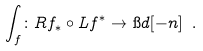<formula> <loc_0><loc_0><loc_500><loc_500>\int _ { f } \colon R f _ { * } \circ L f ^ { * } \to \i d [ - n ] \ .</formula> 